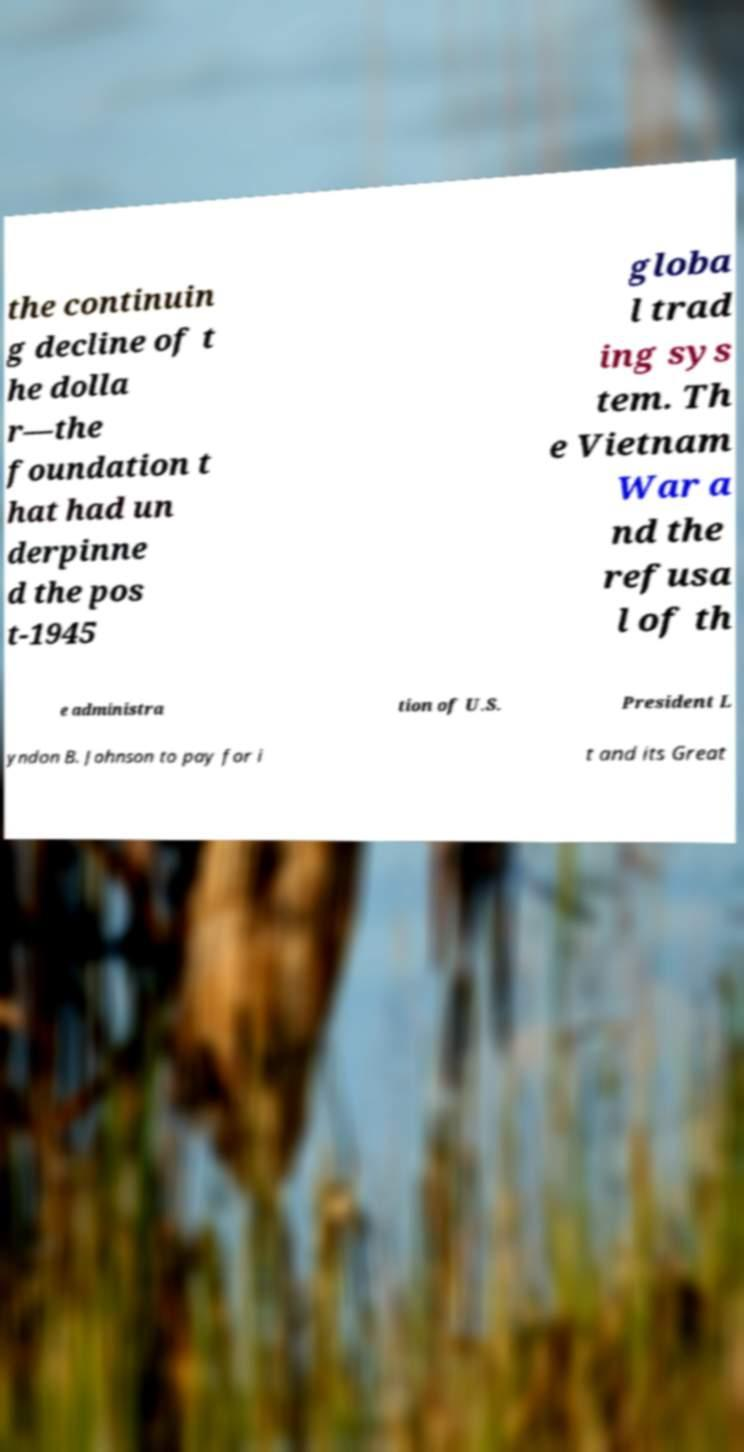There's text embedded in this image that I need extracted. Can you transcribe it verbatim? the continuin g decline of t he dolla r—the foundation t hat had un derpinne d the pos t-1945 globa l trad ing sys tem. Th e Vietnam War a nd the refusa l of th e administra tion of U.S. President L yndon B. Johnson to pay for i t and its Great 